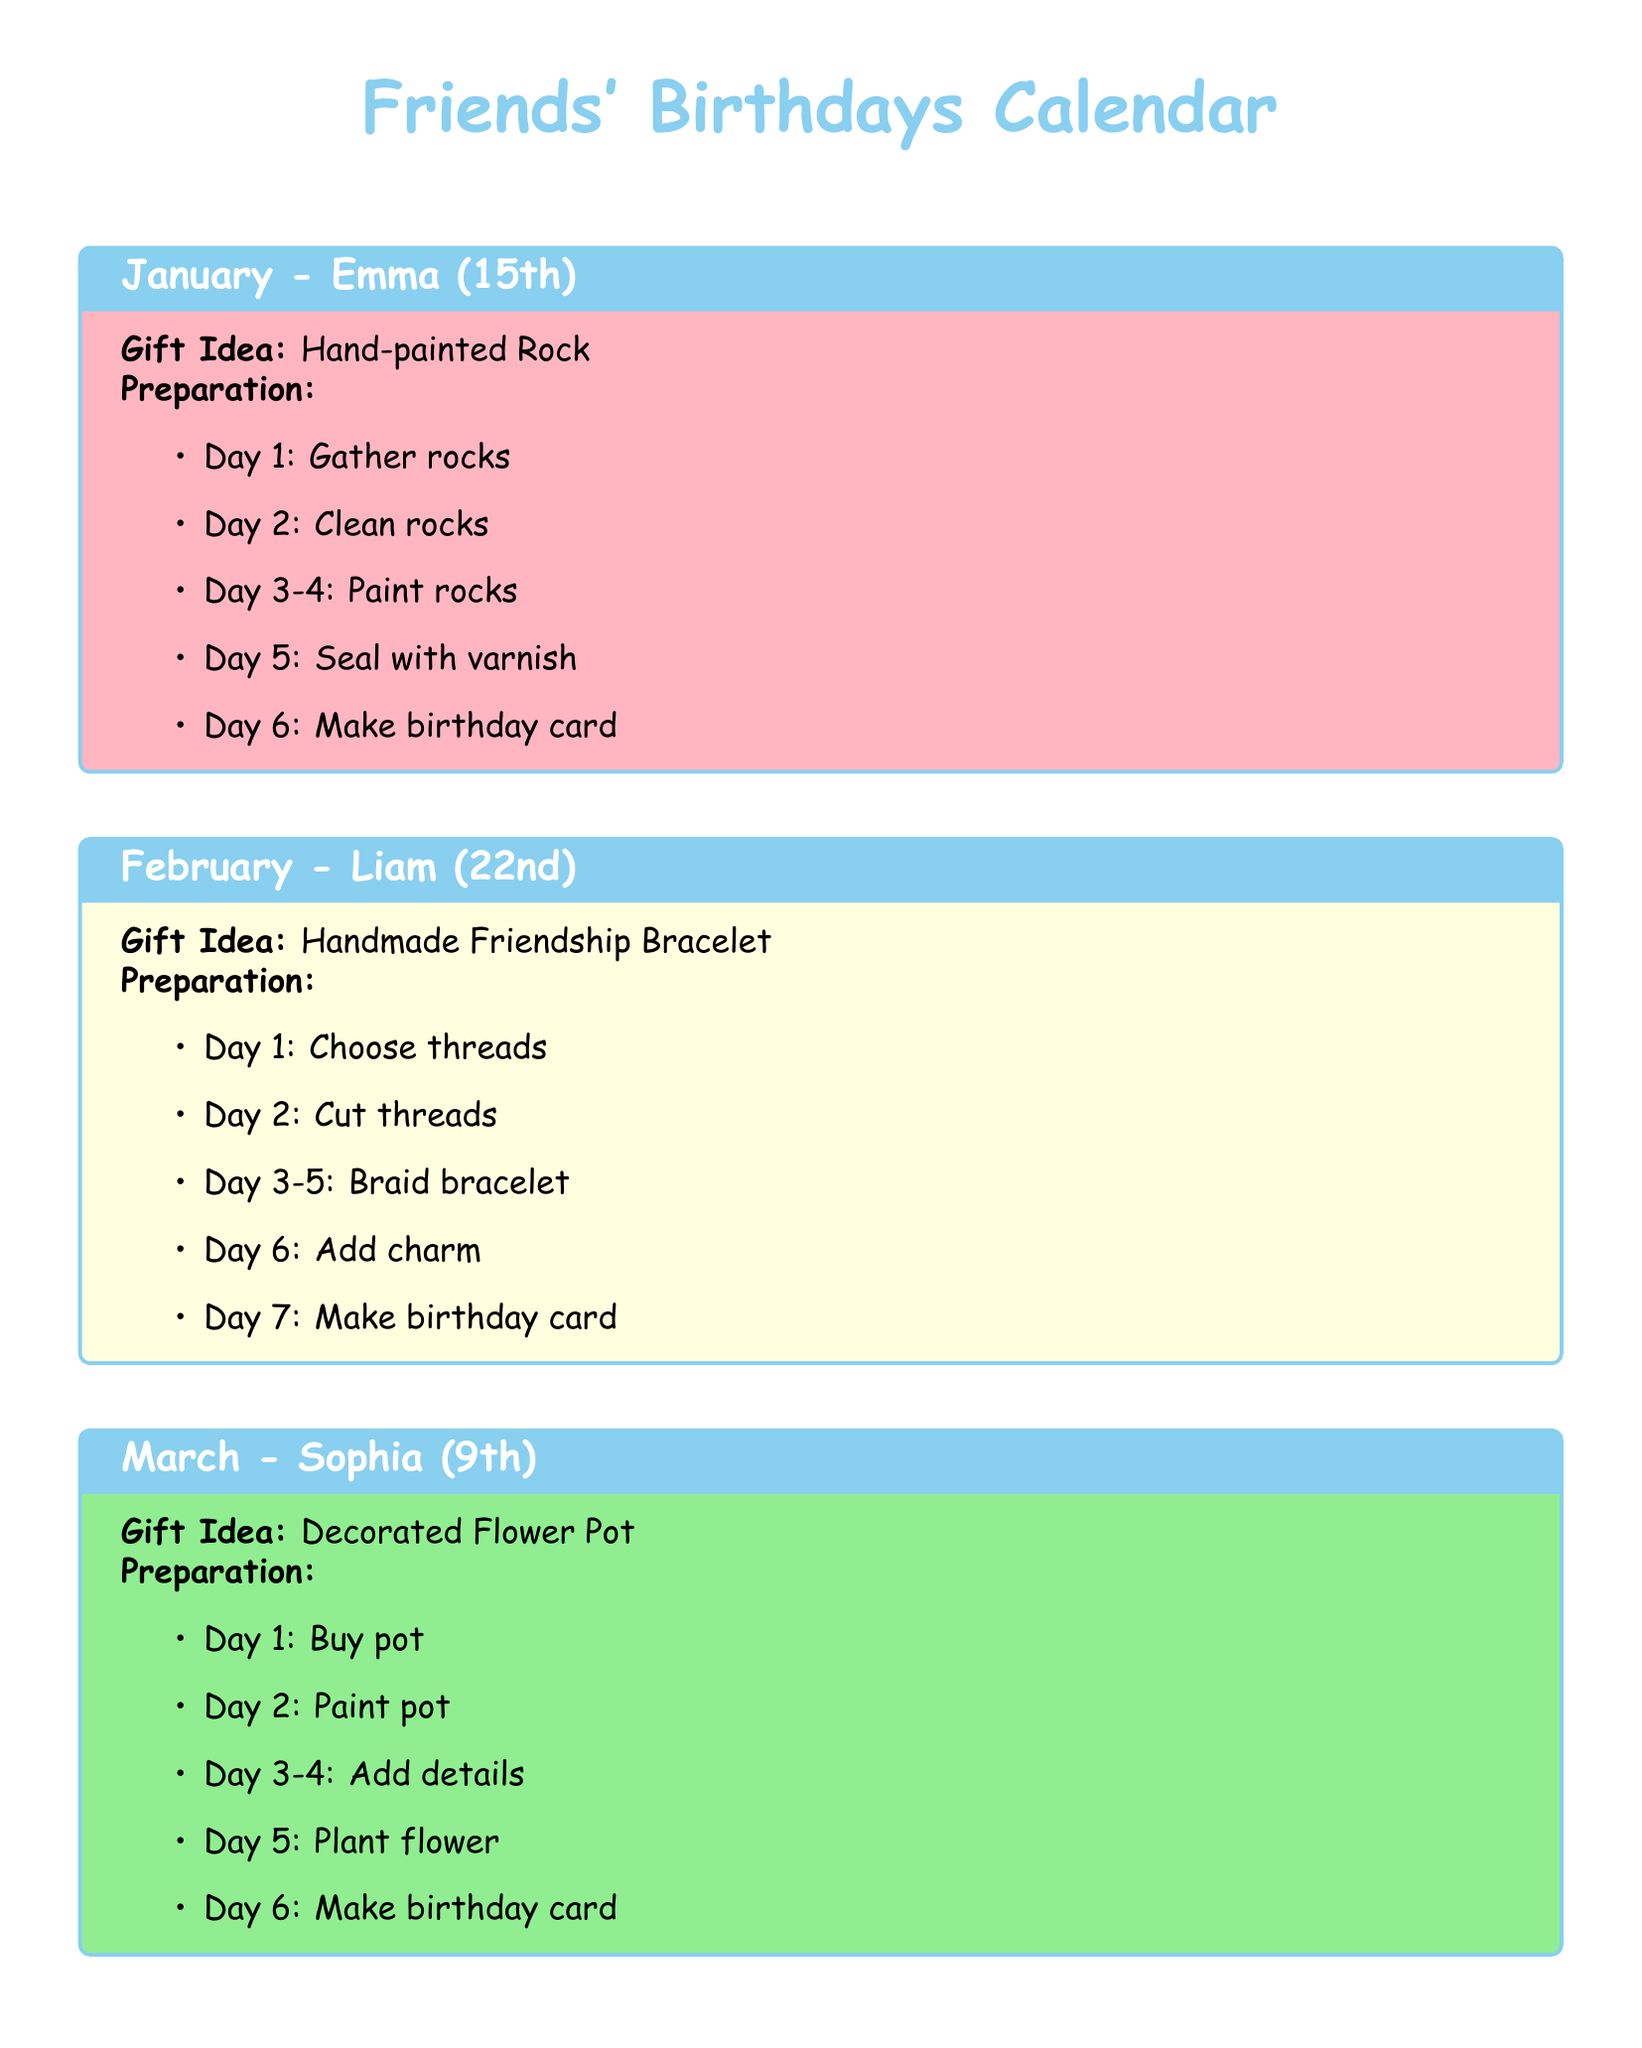What is the birthday date of Emma? Emma's birthday is listed as the 15th of January in the document.
Answer: 15th What is the gift idea for Liam? The document specifies that for Liam, the gift idea is a Handmade Friendship Bracelet.
Answer: Handmade Friendship Bracelet How many days are allocated for preparing Ava's gift? The preparation for Ava's gift spans six days as outlined in the preparation steps.
Answer: 6 What type of gift is being prepared for Sophia? Sophia's gifts are categorized under Decorated Flower Pot in the Calendar.
Answer: Decorated Flower Pot On which day is the birthday card made for Noah? The preparation items for Noah include making the birthday card on day 6.
Answer: Day 6 How many flowers are planted for Sophia's gift? The gift preparation details for Sophia include planting one flower in the pot.
Answer: One flower What is the first step in making a Paper Mache Animal for Noah? The first step in Noah's gift preparation is to prepare materials.
Answer: Prepare materials How many days does it take to braid Liam's bracelet? The document shows that the braiding of the bracelet takes three days.
Answer: 3 days 